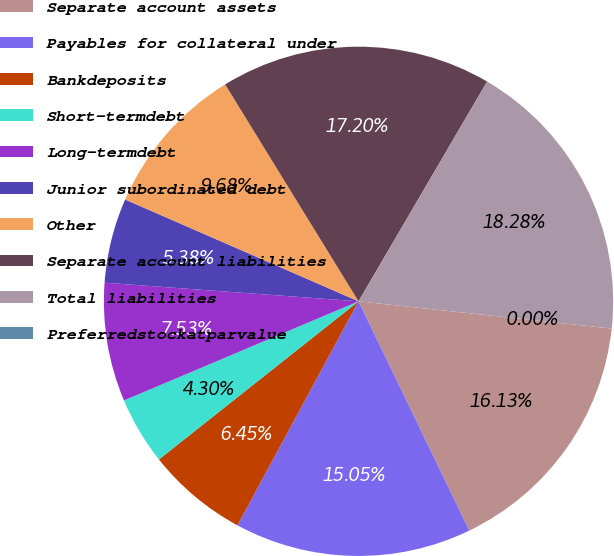Convert chart. <chart><loc_0><loc_0><loc_500><loc_500><pie_chart><fcel>Separate account assets<fcel>Payables for collateral under<fcel>Bankdeposits<fcel>Short-termdebt<fcel>Long-termdebt<fcel>Junior subordinated debt<fcel>Other<fcel>Separate account liabilities<fcel>Total liabilities<fcel>Preferredstockatparvalue<nl><fcel>16.13%<fcel>15.05%<fcel>6.45%<fcel>4.3%<fcel>7.53%<fcel>5.38%<fcel>9.68%<fcel>17.2%<fcel>18.28%<fcel>0.0%<nl></chart> 